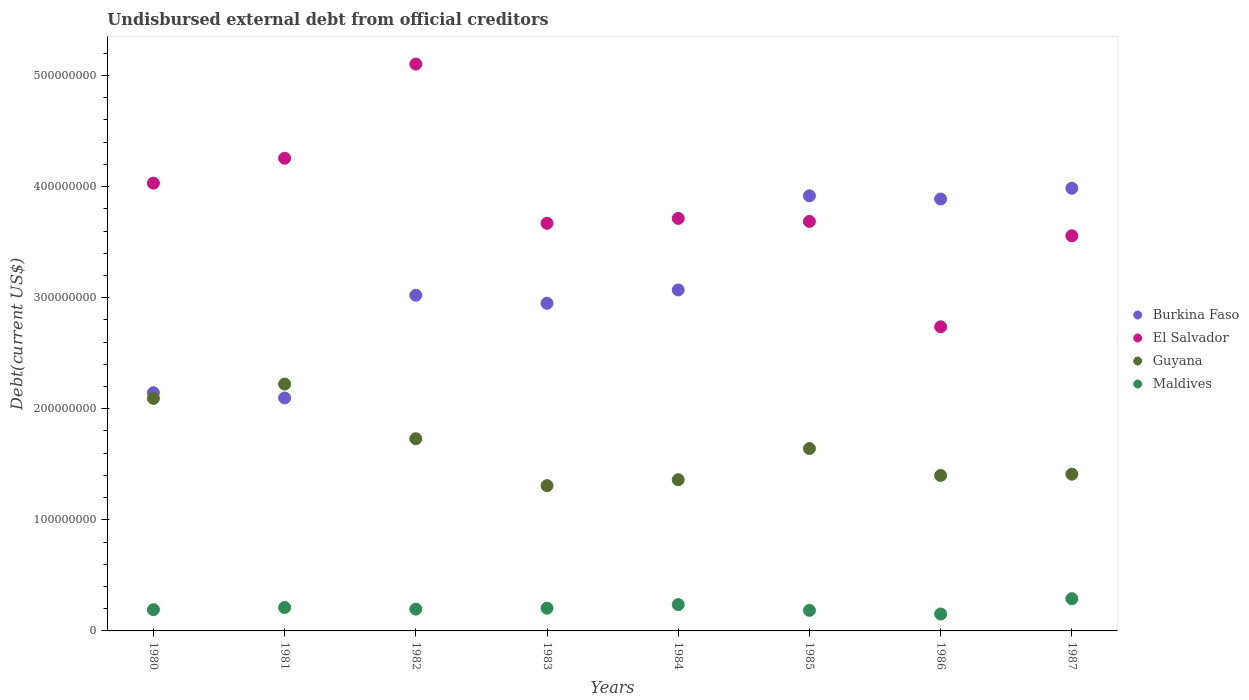What is the total debt in Burkina Faso in 1985?
Keep it short and to the point. 3.92e+08. Across all years, what is the maximum total debt in Guyana?
Your response must be concise. 2.22e+08. Across all years, what is the minimum total debt in Burkina Faso?
Your response must be concise. 2.10e+08. In which year was the total debt in Burkina Faso maximum?
Offer a terse response. 1987. What is the total total debt in Burkina Faso in the graph?
Offer a very short reply. 2.51e+09. What is the difference between the total debt in Maldives in 1980 and that in 1985?
Your answer should be very brief. 6.35e+05. What is the difference between the total debt in Maldives in 1985 and the total debt in Burkina Faso in 1986?
Make the answer very short. -3.70e+08. What is the average total debt in El Salvador per year?
Ensure brevity in your answer.  3.84e+08. In the year 1983, what is the difference between the total debt in Maldives and total debt in El Salvador?
Your answer should be very brief. -3.47e+08. What is the ratio of the total debt in Guyana in 1983 to that in 1984?
Your response must be concise. 0.96. Is the total debt in Burkina Faso in 1980 less than that in 1985?
Make the answer very short. Yes. What is the difference between the highest and the second highest total debt in El Salvador?
Ensure brevity in your answer.  8.48e+07. What is the difference between the highest and the lowest total debt in Burkina Faso?
Make the answer very short. 1.89e+08. Is it the case that in every year, the sum of the total debt in Burkina Faso and total debt in El Salvador  is greater than the total debt in Guyana?
Make the answer very short. Yes. Does the total debt in El Salvador monotonically increase over the years?
Provide a succinct answer. No. How many dotlines are there?
Provide a short and direct response. 4. Where does the legend appear in the graph?
Provide a succinct answer. Center right. What is the title of the graph?
Keep it short and to the point. Undisbursed external debt from official creditors. What is the label or title of the X-axis?
Ensure brevity in your answer.  Years. What is the label or title of the Y-axis?
Your answer should be very brief. Debt(current US$). What is the Debt(current US$) of Burkina Faso in 1980?
Your response must be concise. 2.14e+08. What is the Debt(current US$) in El Salvador in 1980?
Your response must be concise. 4.03e+08. What is the Debt(current US$) of Guyana in 1980?
Ensure brevity in your answer.  2.09e+08. What is the Debt(current US$) of Maldives in 1980?
Make the answer very short. 1.91e+07. What is the Debt(current US$) of Burkina Faso in 1981?
Your response must be concise. 2.10e+08. What is the Debt(current US$) in El Salvador in 1981?
Your response must be concise. 4.26e+08. What is the Debt(current US$) of Guyana in 1981?
Offer a terse response. 2.22e+08. What is the Debt(current US$) in Maldives in 1981?
Provide a succinct answer. 2.11e+07. What is the Debt(current US$) of Burkina Faso in 1982?
Your answer should be compact. 3.02e+08. What is the Debt(current US$) in El Salvador in 1982?
Your answer should be compact. 5.10e+08. What is the Debt(current US$) of Guyana in 1982?
Ensure brevity in your answer.  1.73e+08. What is the Debt(current US$) in Maldives in 1982?
Offer a very short reply. 1.96e+07. What is the Debt(current US$) in Burkina Faso in 1983?
Keep it short and to the point. 2.95e+08. What is the Debt(current US$) of El Salvador in 1983?
Your answer should be very brief. 3.67e+08. What is the Debt(current US$) in Guyana in 1983?
Offer a terse response. 1.31e+08. What is the Debt(current US$) in Maldives in 1983?
Offer a terse response. 2.05e+07. What is the Debt(current US$) in Burkina Faso in 1984?
Your response must be concise. 3.07e+08. What is the Debt(current US$) in El Salvador in 1984?
Keep it short and to the point. 3.71e+08. What is the Debt(current US$) of Guyana in 1984?
Your answer should be compact. 1.36e+08. What is the Debt(current US$) of Maldives in 1984?
Your response must be concise. 2.37e+07. What is the Debt(current US$) in Burkina Faso in 1985?
Provide a succinct answer. 3.92e+08. What is the Debt(current US$) of El Salvador in 1985?
Keep it short and to the point. 3.69e+08. What is the Debt(current US$) in Guyana in 1985?
Your answer should be very brief. 1.64e+08. What is the Debt(current US$) of Maldives in 1985?
Offer a very short reply. 1.85e+07. What is the Debt(current US$) of Burkina Faso in 1986?
Your answer should be compact. 3.89e+08. What is the Debt(current US$) in El Salvador in 1986?
Offer a terse response. 2.74e+08. What is the Debt(current US$) of Guyana in 1986?
Offer a very short reply. 1.40e+08. What is the Debt(current US$) of Maldives in 1986?
Your answer should be compact. 1.52e+07. What is the Debt(current US$) in Burkina Faso in 1987?
Ensure brevity in your answer.  3.98e+08. What is the Debt(current US$) in El Salvador in 1987?
Offer a terse response. 3.56e+08. What is the Debt(current US$) of Guyana in 1987?
Offer a very short reply. 1.41e+08. What is the Debt(current US$) of Maldives in 1987?
Your response must be concise. 2.90e+07. Across all years, what is the maximum Debt(current US$) in Burkina Faso?
Your answer should be very brief. 3.98e+08. Across all years, what is the maximum Debt(current US$) of El Salvador?
Keep it short and to the point. 5.10e+08. Across all years, what is the maximum Debt(current US$) in Guyana?
Make the answer very short. 2.22e+08. Across all years, what is the maximum Debt(current US$) of Maldives?
Your answer should be very brief. 2.90e+07. Across all years, what is the minimum Debt(current US$) in Burkina Faso?
Your answer should be compact. 2.10e+08. Across all years, what is the minimum Debt(current US$) of El Salvador?
Provide a short and direct response. 2.74e+08. Across all years, what is the minimum Debt(current US$) in Guyana?
Offer a very short reply. 1.31e+08. Across all years, what is the minimum Debt(current US$) of Maldives?
Give a very brief answer. 1.52e+07. What is the total Debt(current US$) of Burkina Faso in the graph?
Provide a succinct answer. 2.51e+09. What is the total Debt(current US$) in El Salvador in the graph?
Ensure brevity in your answer.  3.08e+09. What is the total Debt(current US$) of Guyana in the graph?
Offer a terse response. 1.32e+09. What is the total Debt(current US$) in Maldives in the graph?
Provide a succinct answer. 1.67e+08. What is the difference between the Debt(current US$) of Burkina Faso in 1980 and that in 1981?
Give a very brief answer. 4.70e+06. What is the difference between the Debt(current US$) of El Salvador in 1980 and that in 1981?
Offer a very short reply. -2.24e+07. What is the difference between the Debt(current US$) in Guyana in 1980 and that in 1981?
Make the answer very short. -1.29e+07. What is the difference between the Debt(current US$) in Maldives in 1980 and that in 1981?
Keep it short and to the point. -1.99e+06. What is the difference between the Debt(current US$) in Burkina Faso in 1980 and that in 1982?
Your answer should be very brief. -8.78e+07. What is the difference between the Debt(current US$) in El Salvador in 1980 and that in 1982?
Provide a succinct answer. -1.07e+08. What is the difference between the Debt(current US$) in Guyana in 1980 and that in 1982?
Make the answer very short. 3.63e+07. What is the difference between the Debt(current US$) in Maldives in 1980 and that in 1982?
Your answer should be compact. -4.82e+05. What is the difference between the Debt(current US$) of Burkina Faso in 1980 and that in 1983?
Give a very brief answer. -8.05e+07. What is the difference between the Debt(current US$) in El Salvador in 1980 and that in 1983?
Offer a very short reply. 3.61e+07. What is the difference between the Debt(current US$) in Guyana in 1980 and that in 1983?
Your answer should be very brief. 7.85e+07. What is the difference between the Debt(current US$) of Maldives in 1980 and that in 1983?
Provide a succinct answer. -1.34e+06. What is the difference between the Debt(current US$) of Burkina Faso in 1980 and that in 1984?
Make the answer very short. -9.26e+07. What is the difference between the Debt(current US$) of El Salvador in 1980 and that in 1984?
Provide a short and direct response. 3.18e+07. What is the difference between the Debt(current US$) in Guyana in 1980 and that in 1984?
Your response must be concise. 7.32e+07. What is the difference between the Debt(current US$) in Maldives in 1980 and that in 1984?
Offer a terse response. -4.59e+06. What is the difference between the Debt(current US$) of Burkina Faso in 1980 and that in 1985?
Your answer should be compact. -1.77e+08. What is the difference between the Debt(current US$) of El Salvador in 1980 and that in 1985?
Provide a succinct answer. 3.45e+07. What is the difference between the Debt(current US$) of Guyana in 1980 and that in 1985?
Provide a short and direct response. 4.51e+07. What is the difference between the Debt(current US$) in Maldives in 1980 and that in 1985?
Make the answer very short. 6.35e+05. What is the difference between the Debt(current US$) of Burkina Faso in 1980 and that in 1986?
Provide a succinct answer. -1.74e+08. What is the difference between the Debt(current US$) of El Salvador in 1980 and that in 1986?
Your answer should be compact. 1.29e+08. What is the difference between the Debt(current US$) of Guyana in 1980 and that in 1986?
Give a very brief answer. 6.93e+07. What is the difference between the Debt(current US$) in Maldives in 1980 and that in 1986?
Provide a succinct answer. 3.90e+06. What is the difference between the Debt(current US$) in Burkina Faso in 1980 and that in 1987?
Ensure brevity in your answer.  -1.84e+08. What is the difference between the Debt(current US$) of El Salvador in 1980 and that in 1987?
Make the answer very short. 4.74e+07. What is the difference between the Debt(current US$) in Guyana in 1980 and that in 1987?
Make the answer very short. 6.82e+07. What is the difference between the Debt(current US$) in Maldives in 1980 and that in 1987?
Give a very brief answer. -9.90e+06. What is the difference between the Debt(current US$) of Burkina Faso in 1981 and that in 1982?
Offer a terse response. -9.25e+07. What is the difference between the Debt(current US$) in El Salvador in 1981 and that in 1982?
Provide a short and direct response. -8.48e+07. What is the difference between the Debt(current US$) in Guyana in 1981 and that in 1982?
Provide a succinct answer. 4.92e+07. What is the difference between the Debt(current US$) in Maldives in 1981 and that in 1982?
Give a very brief answer. 1.50e+06. What is the difference between the Debt(current US$) of Burkina Faso in 1981 and that in 1983?
Make the answer very short. -8.52e+07. What is the difference between the Debt(current US$) of El Salvador in 1981 and that in 1983?
Your response must be concise. 5.85e+07. What is the difference between the Debt(current US$) of Guyana in 1981 and that in 1983?
Your answer should be very brief. 9.15e+07. What is the difference between the Debt(current US$) of Maldives in 1981 and that in 1983?
Keep it short and to the point. 6.47e+05. What is the difference between the Debt(current US$) of Burkina Faso in 1981 and that in 1984?
Make the answer very short. -9.73e+07. What is the difference between the Debt(current US$) of El Salvador in 1981 and that in 1984?
Provide a short and direct response. 5.41e+07. What is the difference between the Debt(current US$) of Guyana in 1981 and that in 1984?
Your answer should be compact. 8.61e+07. What is the difference between the Debt(current US$) in Maldives in 1981 and that in 1984?
Give a very brief answer. -2.61e+06. What is the difference between the Debt(current US$) in Burkina Faso in 1981 and that in 1985?
Offer a very short reply. -1.82e+08. What is the difference between the Debt(current US$) in El Salvador in 1981 and that in 1985?
Your answer should be compact. 5.69e+07. What is the difference between the Debt(current US$) in Guyana in 1981 and that in 1985?
Make the answer very short. 5.80e+07. What is the difference between the Debt(current US$) in Maldives in 1981 and that in 1985?
Offer a terse response. 2.62e+06. What is the difference between the Debt(current US$) in Burkina Faso in 1981 and that in 1986?
Offer a terse response. -1.79e+08. What is the difference between the Debt(current US$) of El Salvador in 1981 and that in 1986?
Keep it short and to the point. 1.52e+08. What is the difference between the Debt(current US$) in Guyana in 1981 and that in 1986?
Give a very brief answer. 8.23e+07. What is the difference between the Debt(current US$) in Maldives in 1981 and that in 1986?
Keep it short and to the point. 5.89e+06. What is the difference between the Debt(current US$) of Burkina Faso in 1981 and that in 1987?
Keep it short and to the point. -1.89e+08. What is the difference between the Debt(current US$) of El Salvador in 1981 and that in 1987?
Provide a short and direct response. 6.98e+07. What is the difference between the Debt(current US$) of Guyana in 1981 and that in 1987?
Give a very brief answer. 8.11e+07. What is the difference between the Debt(current US$) in Maldives in 1981 and that in 1987?
Keep it short and to the point. -7.91e+06. What is the difference between the Debt(current US$) in Burkina Faso in 1982 and that in 1983?
Offer a terse response. 7.24e+06. What is the difference between the Debt(current US$) of El Salvador in 1982 and that in 1983?
Your answer should be very brief. 1.43e+08. What is the difference between the Debt(current US$) in Guyana in 1982 and that in 1983?
Give a very brief answer. 4.23e+07. What is the difference between the Debt(current US$) of Maldives in 1982 and that in 1983?
Your answer should be compact. -8.57e+05. What is the difference between the Debt(current US$) in Burkina Faso in 1982 and that in 1984?
Make the answer very short. -4.80e+06. What is the difference between the Debt(current US$) of El Salvador in 1982 and that in 1984?
Offer a very short reply. 1.39e+08. What is the difference between the Debt(current US$) of Guyana in 1982 and that in 1984?
Ensure brevity in your answer.  3.69e+07. What is the difference between the Debt(current US$) of Maldives in 1982 and that in 1984?
Give a very brief answer. -4.11e+06. What is the difference between the Debt(current US$) of Burkina Faso in 1982 and that in 1985?
Make the answer very short. -8.95e+07. What is the difference between the Debt(current US$) of El Salvador in 1982 and that in 1985?
Your response must be concise. 1.42e+08. What is the difference between the Debt(current US$) of Guyana in 1982 and that in 1985?
Provide a short and direct response. 8.86e+06. What is the difference between the Debt(current US$) of Maldives in 1982 and that in 1985?
Your response must be concise. 1.12e+06. What is the difference between the Debt(current US$) in Burkina Faso in 1982 and that in 1986?
Your response must be concise. -8.66e+07. What is the difference between the Debt(current US$) of El Salvador in 1982 and that in 1986?
Offer a very short reply. 2.37e+08. What is the difference between the Debt(current US$) in Guyana in 1982 and that in 1986?
Offer a very short reply. 3.31e+07. What is the difference between the Debt(current US$) in Maldives in 1982 and that in 1986?
Provide a succinct answer. 4.38e+06. What is the difference between the Debt(current US$) of Burkina Faso in 1982 and that in 1987?
Offer a very short reply. -9.63e+07. What is the difference between the Debt(current US$) of El Salvador in 1982 and that in 1987?
Keep it short and to the point. 1.55e+08. What is the difference between the Debt(current US$) of Guyana in 1982 and that in 1987?
Offer a terse response. 3.19e+07. What is the difference between the Debt(current US$) in Maldives in 1982 and that in 1987?
Your response must be concise. -9.42e+06. What is the difference between the Debt(current US$) of Burkina Faso in 1983 and that in 1984?
Keep it short and to the point. -1.20e+07. What is the difference between the Debt(current US$) of El Salvador in 1983 and that in 1984?
Offer a terse response. -4.39e+06. What is the difference between the Debt(current US$) in Guyana in 1983 and that in 1984?
Your response must be concise. -5.34e+06. What is the difference between the Debt(current US$) in Maldives in 1983 and that in 1984?
Keep it short and to the point. -3.25e+06. What is the difference between the Debt(current US$) of Burkina Faso in 1983 and that in 1985?
Ensure brevity in your answer.  -9.68e+07. What is the difference between the Debt(current US$) of El Salvador in 1983 and that in 1985?
Offer a very short reply. -1.68e+06. What is the difference between the Debt(current US$) in Guyana in 1983 and that in 1985?
Provide a short and direct response. -3.34e+07. What is the difference between the Debt(current US$) in Maldives in 1983 and that in 1985?
Make the answer very short. 1.97e+06. What is the difference between the Debt(current US$) in Burkina Faso in 1983 and that in 1986?
Give a very brief answer. -9.39e+07. What is the difference between the Debt(current US$) of El Salvador in 1983 and that in 1986?
Give a very brief answer. 9.32e+07. What is the difference between the Debt(current US$) in Guyana in 1983 and that in 1986?
Your answer should be compact. -9.17e+06. What is the difference between the Debt(current US$) in Maldives in 1983 and that in 1986?
Ensure brevity in your answer.  5.24e+06. What is the difference between the Debt(current US$) of Burkina Faso in 1983 and that in 1987?
Make the answer very short. -1.04e+08. What is the difference between the Debt(current US$) of El Salvador in 1983 and that in 1987?
Your answer should be very brief. 1.13e+07. What is the difference between the Debt(current US$) of Guyana in 1983 and that in 1987?
Ensure brevity in your answer.  -1.03e+07. What is the difference between the Debt(current US$) in Maldives in 1983 and that in 1987?
Offer a terse response. -8.56e+06. What is the difference between the Debt(current US$) of Burkina Faso in 1984 and that in 1985?
Keep it short and to the point. -8.47e+07. What is the difference between the Debt(current US$) of El Salvador in 1984 and that in 1985?
Your response must be concise. 2.71e+06. What is the difference between the Debt(current US$) in Guyana in 1984 and that in 1985?
Your response must be concise. -2.81e+07. What is the difference between the Debt(current US$) in Maldives in 1984 and that in 1985?
Offer a terse response. 5.23e+06. What is the difference between the Debt(current US$) of Burkina Faso in 1984 and that in 1986?
Your answer should be compact. -8.18e+07. What is the difference between the Debt(current US$) of El Salvador in 1984 and that in 1986?
Ensure brevity in your answer.  9.76e+07. What is the difference between the Debt(current US$) in Guyana in 1984 and that in 1986?
Make the answer very short. -3.84e+06. What is the difference between the Debt(current US$) of Maldives in 1984 and that in 1986?
Make the answer very short. 8.49e+06. What is the difference between the Debt(current US$) of Burkina Faso in 1984 and that in 1987?
Offer a very short reply. -9.15e+07. What is the difference between the Debt(current US$) in El Salvador in 1984 and that in 1987?
Keep it short and to the point. 1.56e+07. What is the difference between the Debt(current US$) of Guyana in 1984 and that in 1987?
Make the answer very short. -4.99e+06. What is the difference between the Debt(current US$) of Maldives in 1984 and that in 1987?
Your answer should be very brief. -5.31e+06. What is the difference between the Debt(current US$) of Burkina Faso in 1985 and that in 1986?
Your answer should be compact. 2.89e+06. What is the difference between the Debt(current US$) of El Salvador in 1985 and that in 1986?
Provide a short and direct response. 9.49e+07. What is the difference between the Debt(current US$) of Guyana in 1985 and that in 1986?
Offer a very short reply. 2.42e+07. What is the difference between the Debt(current US$) of Maldives in 1985 and that in 1986?
Offer a very short reply. 3.27e+06. What is the difference between the Debt(current US$) of Burkina Faso in 1985 and that in 1987?
Provide a succinct answer. -6.79e+06. What is the difference between the Debt(current US$) in El Salvador in 1985 and that in 1987?
Give a very brief answer. 1.29e+07. What is the difference between the Debt(current US$) of Guyana in 1985 and that in 1987?
Your answer should be compact. 2.31e+07. What is the difference between the Debt(current US$) in Maldives in 1985 and that in 1987?
Make the answer very short. -1.05e+07. What is the difference between the Debt(current US$) in Burkina Faso in 1986 and that in 1987?
Provide a succinct answer. -9.67e+06. What is the difference between the Debt(current US$) of El Salvador in 1986 and that in 1987?
Keep it short and to the point. -8.19e+07. What is the difference between the Debt(current US$) in Guyana in 1986 and that in 1987?
Provide a short and direct response. -1.16e+06. What is the difference between the Debt(current US$) of Maldives in 1986 and that in 1987?
Your answer should be very brief. -1.38e+07. What is the difference between the Debt(current US$) in Burkina Faso in 1980 and the Debt(current US$) in El Salvador in 1981?
Your answer should be very brief. -2.11e+08. What is the difference between the Debt(current US$) of Burkina Faso in 1980 and the Debt(current US$) of Guyana in 1981?
Ensure brevity in your answer.  -7.81e+06. What is the difference between the Debt(current US$) of Burkina Faso in 1980 and the Debt(current US$) of Maldives in 1981?
Provide a succinct answer. 1.93e+08. What is the difference between the Debt(current US$) of El Salvador in 1980 and the Debt(current US$) of Guyana in 1981?
Your answer should be very brief. 1.81e+08. What is the difference between the Debt(current US$) of El Salvador in 1980 and the Debt(current US$) of Maldives in 1981?
Your response must be concise. 3.82e+08. What is the difference between the Debt(current US$) in Guyana in 1980 and the Debt(current US$) in Maldives in 1981?
Make the answer very short. 1.88e+08. What is the difference between the Debt(current US$) of Burkina Faso in 1980 and the Debt(current US$) of El Salvador in 1982?
Offer a very short reply. -2.96e+08. What is the difference between the Debt(current US$) in Burkina Faso in 1980 and the Debt(current US$) in Guyana in 1982?
Ensure brevity in your answer.  4.14e+07. What is the difference between the Debt(current US$) of Burkina Faso in 1980 and the Debt(current US$) of Maldives in 1982?
Your response must be concise. 1.95e+08. What is the difference between the Debt(current US$) of El Salvador in 1980 and the Debt(current US$) of Guyana in 1982?
Your answer should be very brief. 2.30e+08. What is the difference between the Debt(current US$) in El Salvador in 1980 and the Debt(current US$) in Maldives in 1982?
Your answer should be very brief. 3.84e+08. What is the difference between the Debt(current US$) of Guyana in 1980 and the Debt(current US$) of Maldives in 1982?
Keep it short and to the point. 1.90e+08. What is the difference between the Debt(current US$) in Burkina Faso in 1980 and the Debt(current US$) in El Salvador in 1983?
Offer a very short reply. -1.53e+08. What is the difference between the Debt(current US$) of Burkina Faso in 1980 and the Debt(current US$) of Guyana in 1983?
Provide a short and direct response. 8.36e+07. What is the difference between the Debt(current US$) of Burkina Faso in 1980 and the Debt(current US$) of Maldives in 1983?
Your answer should be compact. 1.94e+08. What is the difference between the Debt(current US$) of El Salvador in 1980 and the Debt(current US$) of Guyana in 1983?
Make the answer very short. 2.72e+08. What is the difference between the Debt(current US$) in El Salvador in 1980 and the Debt(current US$) in Maldives in 1983?
Give a very brief answer. 3.83e+08. What is the difference between the Debt(current US$) in Guyana in 1980 and the Debt(current US$) in Maldives in 1983?
Your answer should be very brief. 1.89e+08. What is the difference between the Debt(current US$) of Burkina Faso in 1980 and the Debt(current US$) of El Salvador in 1984?
Ensure brevity in your answer.  -1.57e+08. What is the difference between the Debt(current US$) in Burkina Faso in 1980 and the Debt(current US$) in Guyana in 1984?
Offer a terse response. 7.83e+07. What is the difference between the Debt(current US$) of Burkina Faso in 1980 and the Debt(current US$) of Maldives in 1984?
Keep it short and to the point. 1.91e+08. What is the difference between the Debt(current US$) in El Salvador in 1980 and the Debt(current US$) in Guyana in 1984?
Offer a very short reply. 2.67e+08. What is the difference between the Debt(current US$) in El Salvador in 1980 and the Debt(current US$) in Maldives in 1984?
Your answer should be very brief. 3.79e+08. What is the difference between the Debt(current US$) of Guyana in 1980 and the Debt(current US$) of Maldives in 1984?
Make the answer very short. 1.86e+08. What is the difference between the Debt(current US$) in Burkina Faso in 1980 and the Debt(current US$) in El Salvador in 1985?
Your response must be concise. -1.54e+08. What is the difference between the Debt(current US$) in Burkina Faso in 1980 and the Debt(current US$) in Guyana in 1985?
Your response must be concise. 5.02e+07. What is the difference between the Debt(current US$) in Burkina Faso in 1980 and the Debt(current US$) in Maldives in 1985?
Provide a succinct answer. 1.96e+08. What is the difference between the Debt(current US$) in El Salvador in 1980 and the Debt(current US$) in Guyana in 1985?
Make the answer very short. 2.39e+08. What is the difference between the Debt(current US$) in El Salvador in 1980 and the Debt(current US$) in Maldives in 1985?
Your response must be concise. 3.85e+08. What is the difference between the Debt(current US$) of Guyana in 1980 and the Debt(current US$) of Maldives in 1985?
Offer a very short reply. 1.91e+08. What is the difference between the Debt(current US$) of Burkina Faso in 1980 and the Debt(current US$) of El Salvador in 1986?
Your answer should be very brief. -5.94e+07. What is the difference between the Debt(current US$) in Burkina Faso in 1980 and the Debt(current US$) in Guyana in 1986?
Make the answer very short. 7.45e+07. What is the difference between the Debt(current US$) of Burkina Faso in 1980 and the Debt(current US$) of Maldives in 1986?
Provide a succinct answer. 1.99e+08. What is the difference between the Debt(current US$) of El Salvador in 1980 and the Debt(current US$) of Guyana in 1986?
Give a very brief answer. 2.63e+08. What is the difference between the Debt(current US$) in El Salvador in 1980 and the Debt(current US$) in Maldives in 1986?
Your response must be concise. 3.88e+08. What is the difference between the Debt(current US$) of Guyana in 1980 and the Debt(current US$) of Maldives in 1986?
Make the answer very short. 1.94e+08. What is the difference between the Debt(current US$) in Burkina Faso in 1980 and the Debt(current US$) in El Salvador in 1987?
Ensure brevity in your answer.  -1.41e+08. What is the difference between the Debt(current US$) of Burkina Faso in 1980 and the Debt(current US$) of Guyana in 1987?
Provide a succinct answer. 7.33e+07. What is the difference between the Debt(current US$) of Burkina Faso in 1980 and the Debt(current US$) of Maldives in 1987?
Ensure brevity in your answer.  1.85e+08. What is the difference between the Debt(current US$) in El Salvador in 1980 and the Debt(current US$) in Guyana in 1987?
Your answer should be very brief. 2.62e+08. What is the difference between the Debt(current US$) in El Salvador in 1980 and the Debt(current US$) in Maldives in 1987?
Provide a succinct answer. 3.74e+08. What is the difference between the Debt(current US$) in Guyana in 1980 and the Debt(current US$) in Maldives in 1987?
Provide a succinct answer. 1.80e+08. What is the difference between the Debt(current US$) of Burkina Faso in 1981 and the Debt(current US$) of El Salvador in 1982?
Offer a very short reply. -3.01e+08. What is the difference between the Debt(current US$) of Burkina Faso in 1981 and the Debt(current US$) of Guyana in 1982?
Provide a short and direct response. 3.67e+07. What is the difference between the Debt(current US$) in Burkina Faso in 1981 and the Debt(current US$) in Maldives in 1982?
Give a very brief answer. 1.90e+08. What is the difference between the Debt(current US$) of El Salvador in 1981 and the Debt(current US$) of Guyana in 1982?
Provide a succinct answer. 2.52e+08. What is the difference between the Debt(current US$) of El Salvador in 1981 and the Debt(current US$) of Maldives in 1982?
Your response must be concise. 4.06e+08. What is the difference between the Debt(current US$) in Guyana in 1981 and the Debt(current US$) in Maldives in 1982?
Your answer should be very brief. 2.03e+08. What is the difference between the Debt(current US$) of Burkina Faso in 1981 and the Debt(current US$) of El Salvador in 1983?
Ensure brevity in your answer.  -1.57e+08. What is the difference between the Debt(current US$) of Burkina Faso in 1981 and the Debt(current US$) of Guyana in 1983?
Ensure brevity in your answer.  7.89e+07. What is the difference between the Debt(current US$) in Burkina Faso in 1981 and the Debt(current US$) in Maldives in 1983?
Keep it short and to the point. 1.89e+08. What is the difference between the Debt(current US$) in El Salvador in 1981 and the Debt(current US$) in Guyana in 1983?
Your answer should be compact. 2.95e+08. What is the difference between the Debt(current US$) in El Salvador in 1981 and the Debt(current US$) in Maldives in 1983?
Give a very brief answer. 4.05e+08. What is the difference between the Debt(current US$) in Guyana in 1981 and the Debt(current US$) in Maldives in 1983?
Your answer should be compact. 2.02e+08. What is the difference between the Debt(current US$) of Burkina Faso in 1981 and the Debt(current US$) of El Salvador in 1984?
Your answer should be compact. -1.62e+08. What is the difference between the Debt(current US$) of Burkina Faso in 1981 and the Debt(current US$) of Guyana in 1984?
Provide a short and direct response. 7.36e+07. What is the difference between the Debt(current US$) in Burkina Faso in 1981 and the Debt(current US$) in Maldives in 1984?
Provide a succinct answer. 1.86e+08. What is the difference between the Debt(current US$) in El Salvador in 1981 and the Debt(current US$) in Guyana in 1984?
Make the answer very short. 2.89e+08. What is the difference between the Debt(current US$) in El Salvador in 1981 and the Debt(current US$) in Maldives in 1984?
Offer a terse response. 4.02e+08. What is the difference between the Debt(current US$) of Guyana in 1981 and the Debt(current US$) of Maldives in 1984?
Provide a succinct answer. 1.99e+08. What is the difference between the Debt(current US$) of Burkina Faso in 1981 and the Debt(current US$) of El Salvador in 1985?
Offer a terse response. -1.59e+08. What is the difference between the Debt(current US$) in Burkina Faso in 1981 and the Debt(current US$) in Guyana in 1985?
Offer a terse response. 4.55e+07. What is the difference between the Debt(current US$) in Burkina Faso in 1981 and the Debt(current US$) in Maldives in 1985?
Your answer should be compact. 1.91e+08. What is the difference between the Debt(current US$) of El Salvador in 1981 and the Debt(current US$) of Guyana in 1985?
Offer a very short reply. 2.61e+08. What is the difference between the Debt(current US$) in El Salvador in 1981 and the Debt(current US$) in Maldives in 1985?
Provide a succinct answer. 4.07e+08. What is the difference between the Debt(current US$) in Guyana in 1981 and the Debt(current US$) in Maldives in 1985?
Keep it short and to the point. 2.04e+08. What is the difference between the Debt(current US$) of Burkina Faso in 1981 and the Debt(current US$) of El Salvador in 1986?
Provide a short and direct response. -6.41e+07. What is the difference between the Debt(current US$) in Burkina Faso in 1981 and the Debt(current US$) in Guyana in 1986?
Your answer should be very brief. 6.98e+07. What is the difference between the Debt(current US$) in Burkina Faso in 1981 and the Debt(current US$) in Maldives in 1986?
Make the answer very short. 1.94e+08. What is the difference between the Debt(current US$) of El Salvador in 1981 and the Debt(current US$) of Guyana in 1986?
Your response must be concise. 2.86e+08. What is the difference between the Debt(current US$) of El Salvador in 1981 and the Debt(current US$) of Maldives in 1986?
Provide a short and direct response. 4.10e+08. What is the difference between the Debt(current US$) of Guyana in 1981 and the Debt(current US$) of Maldives in 1986?
Ensure brevity in your answer.  2.07e+08. What is the difference between the Debt(current US$) in Burkina Faso in 1981 and the Debt(current US$) in El Salvador in 1987?
Your answer should be compact. -1.46e+08. What is the difference between the Debt(current US$) of Burkina Faso in 1981 and the Debt(current US$) of Guyana in 1987?
Your answer should be compact. 6.86e+07. What is the difference between the Debt(current US$) in Burkina Faso in 1981 and the Debt(current US$) in Maldives in 1987?
Your response must be concise. 1.81e+08. What is the difference between the Debt(current US$) in El Salvador in 1981 and the Debt(current US$) in Guyana in 1987?
Provide a short and direct response. 2.84e+08. What is the difference between the Debt(current US$) of El Salvador in 1981 and the Debt(current US$) of Maldives in 1987?
Make the answer very short. 3.96e+08. What is the difference between the Debt(current US$) of Guyana in 1981 and the Debt(current US$) of Maldives in 1987?
Provide a short and direct response. 1.93e+08. What is the difference between the Debt(current US$) of Burkina Faso in 1982 and the Debt(current US$) of El Salvador in 1983?
Your response must be concise. -6.48e+07. What is the difference between the Debt(current US$) in Burkina Faso in 1982 and the Debt(current US$) in Guyana in 1983?
Offer a terse response. 1.71e+08. What is the difference between the Debt(current US$) in Burkina Faso in 1982 and the Debt(current US$) in Maldives in 1983?
Keep it short and to the point. 2.82e+08. What is the difference between the Debt(current US$) in El Salvador in 1982 and the Debt(current US$) in Guyana in 1983?
Keep it short and to the point. 3.80e+08. What is the difference between the Debt(current US$) of El Salvador in 1982 and the Debt(current US$) of Maldives in 1983?
Provide a succinct answer. 4.90e+08. What is the difference between the Debt(current US$) in Guyana in 1982 and the Debt(current US$) in Maldives in 1983?
Your response must be concise. 1.53e+08. What is the difference between the Debt(current US$) in Burkina Faso in 1982 and the Debt(current US$) in El Salvador in 1984?
Offer a very short reply. -6.92e+07. What is the difference between the Debt(current US$) in Burkina Faso in 1982 and the Debt(current US$) in Guyana in 1984?
Your response must be concise. 1.66e+08. What is the difference between the Debt(current US$) in Burkina Faso in 1982 and the Debt(current US$) in Maldives in 1984?
Offer a terse response. 2.78e+08. What is the difference between the Debt(current US$) in El Salvador in 1982 and the Debt(current US$) in Guyana in 1984?
Keep it short and to the point. 3.74e+08. What is the difference between the Debt(current US$) in El Salvador in 1982 and the Debt(current US$) in Maldives in 1984?
Make the answer very short. 4.87e+08. What is the difference between the Debt(current US$) of Guyana in 1982 and the Debt(current US$) of Maldives in 1984?
Make the answer very short. 1.49e+08. What is the difference between the Debt(current US$) in Burkina Faso in 1982 and the Debt(current US$) in El Salvador in 1985?
Provide a short and direct response. -6.65e+07. What is the difference between the Debt(current US$) of Burkina Faso in 1982 and the Debt(current US$) of Guyana in 1985?
Offer a very short reply. 1.38e+08. What is the difference between the Debt(current US$) of Burkina Faso in 1982 and the Debt(current US$) of Maldives in 1985?
Provide a short and direct response. 2.84e+08. What is the difference between the Debt(current US$) of El Salvador in 1982 and the Debt(current US$) of Guyana in 1985?
Offer a terse response. 3.46e+08. What is the difference between the Debt(current US$) in El Salvador in 1982 and the Debt(current US$) in Maldives in 1985?
Your response must be concise. 4.92e+08. What is the difference between the Debt(current US$) in Guyana in 1982 and the Debt(current US$) in Maldives in 1985?
Give a very brief answer. 1.55e+08. What is the difference between the Debt(current US$) in Burkina Faso in 1982 and the Debt(current US$) in El Salvador in 1986?
Give a very brief answer. 2.84e+07. What is the difference between the Debt(current US$) of Burkina Faso in 1982 and the Debt(current US$) of Guyana in 1986?
Your answer should be compact. 1.62e+08. What is the difference between the Debt(current US$) of Burkina Faso in 1982 and the Debt(current US$) of Maldives in 1986?
Your answer should be very brief. 2.87e+08. What is the difference between the Debt(current US$) of El Salvador in 1982 and the Debt(current US$) of Guyana in 1986?
Your answer should be compact. 3.70e+08. What is the difference between the Debt(current US$) in El Salvador in 1982 and the Debt(current US$) in Maldives in 1986?
Offer a terse response. 4.95e+08. What is the difference between the Debt(current US$) in Guyana in 1982 and the Debt(current US$) in Maldives in 1986?
Make the answer very short. 1.58e+08. What is the difference between the Debt(current US$) in Burkina Faso in 1982 and the Debt(current US$) in El Salvador in 1987?
Offer a very short reply. -5.35e+07. What is the difference between the Debt(current US$) of Burkina Faso in 1982 and the Debt(current US$) of Guyana in 1987?
Offer a terse response. 1.61e+08. What is the difference between the Debt(current US$) in Burkina Faso in 1982 and the Debt(current US$) in Maldives in 1987?
Provide a short and direct response. 2.73e+08. What is the difference between the Debt(current US$) in El Salvador in 1982 and the Debt(current US$) in Guyana in 1987?
Your response must be concise. 3.69e+08. What is the difference between the Debt(current US$) in El Salvador in 1982 and the Debt(current US$) in Maldives in 1987?
Provide a short and direct response. 4.81e+08. What is the difference between the Debt(current US$) in Guyana in 1982 and the Debt(current US$) in Maldives in 1987?
Offer a very short reply. 1.44e+08. What is the difference between the Debt(current US$) in Burkina Faso in 1983 and the Debt(current US$) in El Salvador in 1984?
Provide a short and direct response. -7.64e+07. What is the difference between the Debt(current US$) in Burkina Faso in 1983 and the Debt(current US$) in Guyana in 1984?
Offer a very short reply. 1.59e+08. What is the difference between the Debt(current US$) in Burkina Faso in 1983 and the Debt(current US$) in Maldives in 1984?
Ensure brevity in your answer.  2.71e+08. What is the difference between the Debt(current US$) of El Salvador in 1983 and the Debt(current US$) of Guyana in 1984?
Give a very brief answer. 2.31e+08. What is the difference between the Debt(current US$) in El Salvador in 1983 and the Debt(current US$) in Maldives in 1984?
Ensure brevity in your answer.  3.43e+08. What is the difference between the Debt(current US$) of Guyana in 1983 and the Debt(current US$) of Maldives in 1984?
Offer a very short reply. 1.07e+08. What is the difference between the Debt(current US$) of Burkina Faso in 1983 and the Debt(current US$) of El Salvador in 1985?
Give a very brief answer. -7.37e+07. What is the difference between the Debt(current US$) in Burkina Faso in 1983 and the Debt(current US$) in Guyana in 1985?
Give a very brief answer. 1.31e+08. What is the difference between the Debt(current US$) of Burkina Faso in 1983 and the Debt(current US$) of Maldives in 1985?
Provide a short and direct response. 2.76e+08. What is the difference between the Debt(current US$) in El Salvador in 1983 and the Debt(current US$) in Guyana in 1985?
Offer a very short reply. 2.03e+08. What is the difference between the Debt(current US$) in El Salvador in 1983 and the Debt(current US$) in Maldives in 1985?
Offer a terse response. 3.48e+08. What is the difference between the Debt(current US$) of Guyana in 1983 and the Debt(current US$) of Maldives in 1985?
Ensure brevity in your answer.  1.12e+08. What is the difference between the Debt(current US$) of Burkina Faso in 1983 and the Debt(current US$) of El Salvador in 1986?
Make the answer very short. 2.12e+07. What is the difference between the Debt(current US$) in Burkina Faso in 1983 and the Debt(current US$) in Guyana in 1986?
Your response must be concise. 1.55e+08. What is the difference between the Debt(current US$) in Burkina Faso in 1983 and the Debt(current US$) in Maldives in 1986?
Your answer should be very brief. 2.80e+08. What is the difference between the Debt(current US$) of El Salvador in 1983 and the Debt(current US$) of Guyana in 1986?
Ensure brevity in your answer.  2.27e+08. What is the difference between the Debt(current US$) of El Salvador in 1983 and the Debt(current US$) of Maldives in 1986?
Provide a succinct answer. 3.52e+08. What is the difference between the Debt(current US$) of Guyana in 1983 and the Debt(current US$) of Maldives in 1986?
Your answer should be very brief. 1.16e+08. What is the difference between the Debt(current US$) in Burkina Faso in 1983 and the Debt(current US$) in El Salvador in 1987?
Give a very brief answer. -6.08e+07. What is the difference between the Debt(current US$) in Burkina Faso in 1983 and the Debt(current US$) in Guyana in 1987?
Your response must be concise. 1.54e+08. What is the difference between the Debt(current US$) of Burkina Faso in 1983 and the Debt(current US$) of Maldives in 1987?
Offer a very short reply. 2.66e+08. What is the difference between the Debt(current US$) of El Salvador in 1983 and the Debt(current US$) of Guyana in 1987?
Give a very brief answer. 2.26e+08. What is the difference between the Debt(current US$) of El Salvador in 1983 and the Debt(current US$) of Maldives in 1987?
Your answer should be compact. 3.38e+08. What is the difference between the Debt(current US$) of Guyana in 1983 and the Debt(current US$) of Maldives in 1987?
Your answer should be compact. 1.02e+08. What is the difference between the Debt(current US$) in Burkina Faso in 1984 and the Debt(current US$) in El Salvador in 1985?
Your response must be concise. -6.17e+07. What is the difference between the Debt(current US$) in Burkina Faso in 1984 and the Debt(current US$) in Guyana in 1985?
Your answer should be very brief. 1.43e+08. What is the difference between the Debt(current US$) of Burkina Faso in 1984 and the Debt(current US$) of Maldives in 1985?
Keep it short and to the point. 2.88e+08. What is the difference between the Debt(current US$) in El Salvador in 1984 and the Debt(current US$) in Guyana in 1985?
Your response must be concise. 2.07e+08. What is the difference between the Debt(current US$) of El Salvador in 1984 and the Debt(current US$) of Maldives in 1985?
Offer a very short reply. 3.53e+08. What is the difference between the Debt(current US$) of Guyana in 1984 and the Debt(current US$) of Maldives in 1985?
Offer a very short reply. 1.18e+08. What is the difference between the Debt(current US$) in Burkina Faso in 1984 and the Debt(current US$) in El Salvador in 1986?
Ensure brevity in your answer.  3.32e+07. What is the difference between the Debt(current US$) in Burkina Faso in 1984 and the Debt(current US$) in Guyana in 1986?
Your answer should be compact. 1.67e+08. What is the difference between the Debt(current US$) in Burkina Faso in 1984 and the Debt(current US$) in Maldives in 1986?
Keep it short and to the point. 2.92e+08. What is the difference between the Debt(current US$) in El Salvador in 1984 and the Debt(current US$) in Guyana in 1986?
Your answer should be compact. 2.31e+08. What is the difference between the Debt(current US$) of El Salvador in 1984 and the Debt(current US$) of Maldives in 1986?
Make the answer very short. 3.56e+08. What is the difference between the Debt(current US$) of Guyana in 1984 and the Debt(current US$) of Maldives in 1986?
Your response must be concise. 1.21e+08. What is the difference between the Debt(current US$) of Burkina Faso in 1984 and the Debt(current US$) of El Salvador in 1987?
Provide a succinct answer. -4.87e+07. What is the difference between the Debt(current US$) of Burkina Faso in 1984 and the Debt(current US$) of Guyana in 1987?
Make the answer very short. 1.66e+08. What is the difference between the Debt(current US$) of Burkina Faso in 1984 and the Debt(current US$) of Maldives in 1987?
Offer a very short reply. 2.78e+08. What is the difference between the Debt(current US$) in El Salvador in 1984 and the Debt(current US$) in Guyana in 1987?
Ensure brevity in your answer.  2.30e+08. What is the difference between the Debt(current US$) of El Salvador in 1984 and the Debt(current US$) of Maldives in 1987?
Offer a terse response. 3.42e+08. What is the difference between the Debt(current US$) of Guyana in 1984 and the Debt(current US$) of Maldives in 1987?
Offer a terse response. 1.07e+08. What is the difference between the Debt(current US$) of Burkina Faso in 1985 and the Debt(current US$) of El Salvador in 1986?
Ensure brevity in your answer.  1.18e+08. What is the difference between the Debt(current US$) of Burkina Faso in 1985 and the Debt(current US$) of Guyana in 1986?
Offer a terse response. 2.52e+08. What is the difference between the Debt(current US$) of Burkina Faso in 1985 and the Debt(current US$) of Maldives in 1986?
Your response must be concise. 3.76e+08. What is the difference between the Debt(current US$) in El Salvador in 1985 and the Debt(current US$) in Guyana in 1986?
Make the answer very short. 2.29e+08. What is the difference between the Debt(current US$) in El Salvador in 1985 and the Debt(current US$) in Maldives in 1986?
Provide a succinct answer. 3.53e+08. What is the difference between the Debt(current US$) in Guyana in 1985 and the Debt(current US$) in Maldives in 1986?
Your answer should be very brief. 1.49e+08. What is the difference between the Debt(current US$) of Burkina Faso in 1985 and the Debt(current US$) of El Salvador in 1987?
Provide a short and direct response. 3.60e+07. What is the difference between the Debt(current US$) of Burkina Faso in 1985 and the Debt(current US$) of Guyana in 1987?
Ensure brevity in your answer.  2.51e+08. What is the difference between the Debt(current US$) of Burkina Faso in 1985 and the Debt(current US$) of Maldives in 1987?
Ensure brevity in your answer.  3.63e+08. What is the difference between the Debt(current US$) of El Salvador in 1985 and the Debt(current US$) of Guyana in 1987?
Keep it short and to the point. 2.28e+08. What is the difference between the Debt(current US$) of El Salvador in 1985 and the Debt(current US$) of Maldives in 1987?
Make the answer very short. 3.40e+08. What is the difference between the Debt(current US$) of Guyana in 1985 and the Debt(current US$) of Maldives in 1987?
Keep it short and to the point. 1.35e+08. What is the difference between the Debt(current US$) in Burkina Faso in 1986 and the Debt(current US$) in El Salvador in 1987?
Provide a short and direct response. 3.31e+07. What is the difference between the Debt(current US$) of Burkina Faso in 1986 and the Debt(current US$) of Guyana in 1987?
Provide a short and direct response. 2.48e+08. What is the difference between the Debt(current US$) of Burkina Faso in 1986 and the Debt(current US$) of Maldives in 1987?
Ensure brevity in your answer.  3.60e+08. What is the difference between the Debt(current US$) in El Salvador in 1986 and the Debt(current US$) in Guyana in 1987?
Your response must be concise. 1.33e+08. What is the difference between the Debt(current US$) of El Salvador in 1986 and the Debt(current US$) of Maldives in 1987?
Give a very brief answer. 2.45e+08. What is the difference between the Debt(current US$) in Guyana in 1986 and the Debt(current US$) in Maldives in 1987?
Offer a terse response. 1.11e+08. What is the average Debt(current US$) of Burkina Faso per year?
Provide a succinct answer. 3.13e+08. What is the average Debt(current US$) in El Salvador per year?
Keep it short and to the point. 3.84e+08. What is the average Debt(current US$) of Guyana per year?
Provide a succinct answer. 1.65e+08. What is the average Debt(current US$) in Maldives per year?
Provide a short and direct response. 2.08e+07. In the year 1980, what is the difference between the Debt(current US$) of Burkina Faso and Debt(current US$) of El Salvador?
Your answer should be compact. -1.89e+08. In the year 1980, what is the difference between the Debt(current US$) in Burkina Faso and Debt(current US$) in Guyana?
Your answer should be very brief. 5.12e+06. In the year 1980, what is the difference between the Debt(current US$) in Burkina Faso and Debt(current US$) in Maldives?
Your answer should be compact. 1.95e+08. In the year 1980, what is the difference between the Debt(current US$) of El Salvador and Debt(current US$) of Guyana?
Provide a short and direct response. 1.94e+08. In the year 1980, what is the difference between the Debt(current US$) in El Salvador and Debt(current US$) in Maldives?
Offer a terse response. 3.84e+08. In the year 1980, what is the difference between the Debt(current US$) in Guyana and Debt(current US$) in Maldives?
Your answer should be very brief. 1.90e+08. In the year 1981, what is the difference between the Debt(current US$) of Burkina Faso and Debt(current US$) of El Salvador?
Make the answer very short. -2.16e+08. In the year 1981, what is the difference between the Debt(current US$) in Burkina Faso and Debt(current US$) in Guyana?
Keep it short and to the point. -1.25e+07. In the year 1981, what is the difference between the Debt(current US$) of Burkina Faso and Debt(current US$) of Maldives?
Keep it short and to the point. 1.89e+08. In the year 1981, what is the difference between the Debt(current US$) of El Salvador and Debt(current US$) of Guyana?
Ensure brevity in your answer.  2.03e+08. In the year 1981, what is the difference between the Debt(current US$) in El Salvador and Debt(current US$) in Maldives?
Give a very brief answer. 4.04e+08. In the year 1981, what is the difference between the Debt(current US$) of Guyana and Debt(current US$) of Maldives?
Your answer should be compact. 2.01e+08. In the year 1982, what is the difference between the Debt(current US$) of Burkina Faso and Debt(current US$) of El Salvador?
Offer a very short reply. -2.08e+08. In the year 1982, what is the difference between the Debt(current US$) of Burkina Faso and Debt(current US$) of Guyana?
Keep it short and to the point. 1.29e+08. In the year 1982, what is the difference between the Debt(current US$) in Burkina Faso and Debt(current US$) in Maldives?
Your answer should be very brief. 2.83e+08. In the year 1982, what is the difference between the Debt(current US$) in El Salvador and Debt(current US$) in Guyana?
Ensure brevity in your answer.  3.37e+08. In the year 1982, what is the difference between the Debt(current US$) of El Salvador and Debt(current US$) of Maldives?
Your answer should be very brief. 4.91e+08. In the year 1982, what is the difference between the Debt(current US$) in Guyana and Debt(current US$) in Maldives?
Your answer should be very brief. 1.53e+08. In the year 1983, what is the difference between the Debt(current US$) in Burkina Faso and Debt(current US$) in El Salvador?
Provide a succinct answer. -7.20e+07. In the year 1983, what is the difference between the Debt(current US$) in Burkina Faso and Debt(current US$) in Guyana?
Your answer should be compact. 1.64e+08. In the year 1983, what is the difference between the Debt(current US$) of Burkina Faso and Debt(current US$) of Maldives?
Your response must be concise. 2.74e+08. In the year 1983, what is the difference between the Debt(current US$) in El Salvador and Debt(current US$) in Guyana?
Your answer should be very brief. 2.36e+08. In the year 1983, what is the difference between the Debt(current US$) in El Salvador and Debt(current US$) in Maldives?
Keep it short and to the point. 3.47e+08. In the year 1983, what is the difference between the Debt(current US$) in Guyana and Debt(current US$) in Maldives?
Your answer should be compact. 1.10e+08. In the year 1984, what is the difference between the Debt(current US$) of Burkina Faso and Debt(current US$) of El Salvador?
Give a very brief answer. -6.44e+07. In the year 1984, what is the difference between the Debt(current US$) of Burkina Faso and Debt(current US$) of Guyana?
Offer a very short reply. 1.71e+08. In the year 1984, what is the difference between the Debt(current US$) of Burkina Faso and Debt(current US$) of Maldives?
Provide a short and direct response. 2.83e+08. In the year 1984, what is the difference between the Debt(current US$) in El Salvador and Debt(current US$) in Guyana?
Offer a very short reply. 2.35e+08. In the year 1984, what is the difference between the Debt(current US$) of El Salvador and Debt(current US$) of Maldives?
Keep it short and to the point. 3.48e+08. In the year 1984, what is the difference between the Debt(current US$) in Guyana and Debt(current US$) in Maldives?
Provide a short and direct response. 1.12e+08. In the year 1985, what is the difference between the Debt(current US$) of Burkina Faso and Debt(current US$) of El Salvador?
Your response must be concise. 2.31e+07. In the year 1985, what is the difference between the Debt(current US$) in Burkina Faso and Debt(current US$) in Guyana?
Provide a short and direct response. 2.28e+08. In the year 1985, what is the difference between the Debt(current US$) of Burkina Faso and Debt(current US$) of Maldives?
Offer a terse response. 3.73e+08. In the year 1985, what is the difference between the Debt(current US$) of El Salvador and Debt(current US$) of Guyana?
Ensure brevity in your answer.  2.04e+08. In the year 1985, what is the difference between the Debt(current US$) of El Salvador and Debt(current US$) of Maldives?
Keep it short and to the point. 3.50e+08. In the year 1985, what is the difference between the Debt(current US$) in Guyana and Debt(current US$) in Maldives?
Make the answer very short. 1.46e+08. In the year 1986, what is the difference between the Debt(current US$) of Burkina Faso and Debt(current US$) of El Salvador?
Keep it short and to the point. 1.15e+08. In the year 1986, what is the difference between the Debt(current US$) in Burkina Faso and Debt(current US$) in Guyana?
Offer a very short reply. 2.49e+08. In the year 1986, what is the difference between the Debt(current US$) in Burkina Faso and Debt(current US$) in Maldives?
Keep it short and to the point. 3.74e+08. In the year 1986, what is the difference between the Debt(current US$) in El Salvador and Debt(current US$) in Guyana?
Offer a very short reply. 1.34e+08. In the year 1986, what is the difference between the Debt(current US$) in El Salvador and Debt(current US$) in Maldives?
Ensure brevity in your answer.  2.59e+08. In the year 1986, what is the difference between the Debt(current US$) of Guyana and Debt(current US$) of Maldives?
Keep it short and to the point. 1.25e+08. In the year 1987, what is the difference between the Debt(current US$) of Burkina Faso and Debt(current US$) of El Salvador?
Your answer should be compact. 4.28e+07. In the year 1987, what is the difference between the Debt(current US$) in Burkina Faso and Debt(current US$) in Guyana?
Your response must be concise. 2.57e+08. In the year 1987, what is the difference between the Debt(current US$) of Burkina Faso and Debt(current US$) of Maldives?
Give a very brief answer. 3.69e+08. In the year 1987, what is the difference between the Debt(current US$) of El Salvador and Debt(current US$) of Guyana?
Provide a short and direct response. 2.15e+08. In the year 1987, what is the difference between the Debt(current US$) in El Salvador and Debt(current US$) in Maldives?
Provide a short and direct response. 3.27e+08. In the year 1987, what is the difference between the Debt(current US$) of Guyana and Debt(current US$) of Maldives?
Offer a terse response. 1.12e+08. What is the ratio of the Debt(current US$) in Burkina Faso in 1980 to that in 1981?
Keep it short and to the point. 1.02. What is the ratio of the Debt(current US$) of El Salvador in 1980 to that in 1981?
Provide a succinct answer. 0.95. What is the ratio of the Debt(current US$) of Guyana in 1980 to that in 1981?
Your answer should be very brief. 0.94. What is the ratio of the Debt(current US$) in Maldives in 1980 to that in 1981?
Give a very brief answer. 0.91. What is the ratio of the Debt(current US$) of Burkina Faso in 1980 to that in 1982?
Offer a terse response. 0.71. What is the ratio of the Debt(current US$) of El Salvador in 1980 to that in 1982?
Provide a short and direct response. 0.79. What is the ratio of the Debt(current US$) of Guyana in 1980 to that in 1982?
Give a very brief answer. 1.21. What is the ratio of the Debt(current US$) of Maldives in 1980 to that in 1982?
Keep it short and to the point. 0.98. What is the ratio of the Debt(current US$) of Burkina Faso in 1980 to that in 1983?
Keep it short and to the point. 0.73. What is the ratio of the Debt(current US$) of El Salvador in 1980 to that in 1983?
Make the answer very short. 1.1. What is the ratio of the Debt(current US$) in Guyana in 1980 to that in 1983?
Make the answer very short. 1.6. What is the ratio of the Debt(current US$) of Maldives in 1980 to that in 1983?
Keep it short and to the point. 0.93. What is the ratio of the Debt(current US$) of Burkina Faso in 1980 to that in 1984?
Provide a succinct answer. 0.7. What is the ratio of the Debt(current US$) of El Salvador in 1980 to that in 1984?
Your answer should be very brief. 1.09. What is the ratio of the Debt(current US$) of Guyana in 1980 to that in 1984?
Your answer should be very brief. 1.54. What is the ratio of the Debt(current US$) in Maldives in 1980 to that in 1984?
Give a very brief answer. 0.81. What is the ratio of the Debt(current US$) in Burkina Faso in 1980 to that in 1985?
Offer a very short reply. 0.55. What is the ratio of the Debt(current US$) of El Salvador in 1980 to that in 1985?
Keep it short and to the point. 1.09. What is the ratio of the Debt(current US$) in Guyana in 1980 to that in 1985?
Ensure brevity in your answer.  1.27. What is the ratio of the Debt(current US$) in Maldives in 1980 to that in 1985?
Provide a succinct answer. 1.03. What is the ratio of the Debt(current US$) of Burkina Faso in 1980 to that in 1986?
Make the answer very short. 0.55. What is the ratio of the Debt(current US$) in El Salvador in 1980 to that in 1986?
Provide a succinct answer. 1.47. What is the ratio of the Debt(current US$) of Guyana in 1980 to that in 1986?
Ensure brevity in your answer.  1.5. What is the ratio of the Debt(current US$) of Maldives in 1980 to that in 1986?
Offer a very short reply. 1.26. What is the ratio of the Debt(current US$) in Burkina Faso in 1980 to that in 1987?
Your answer should be compact. 0.54. What is the ratio of the Debt(current US$) of El Salvador in 1980 to that in 1987?
Give a very brief answer. 1.13. What is the ratio of the Debt(current US$) of Guyana in 1980 to that in 1987?
Provide a succinct answer. 1.48. What is the ratio of the Debt(current US$) in Maldives in 1980 to that in 1987?
Your answer should be very brief. 0.66. What is the ratio of the Debt(current US$) of Burkina Faso in 1981 to that in 1982?
Your answer should be compact. 0.69. What is the ratio of the Debt(current US$) in El Salvador in 1981 to that in 1982?
Provide a short and direct response. 0.83. What is the ratio of the Debt(current US$) in Guyana in 1981 to that in 1982?
Ensure brevity in your answer.  1.28. What is the ratio of the Debt(current US$) of Maldives in 1981 to that in 1982?
Make the answer very short. 1.08. What is the ratio of the Debt(current US$) of Burkina Faso in 1981 to that in 1983?
Your answer should be compact. 0.71. What is the ratio of the Debt(current US$) in El Salvador in 1981 to that in 1983?
Your response must be concise. 1.16. What is the ratio of the Debt(current US$) in Guyana in 1981 to that in 1983?
Offer a terse response. 1.7. What is the ratio of the Debt(current US$) in Maldives in 1981 to that in 1983?
Provide a short and direct response. 1.03. What is the ratio of the Debt(current US$) in Burkina Faso in 1981 to that in 1984?
Your answer should be compact. 0.68. What is the ratio of the Debt(current US$) in El Salvador in 1981 to that in 1984?
Keep it short and to the point. 1.15. What is the ratio of the Debt(current US$) of Guyana in 1981 to that in 1984?
Give a very brief answer. 1.63. What is the ratio of the Debt(current US$) of Maldives in 1981 to that in 1984?
Your answer should be very brief. 0.89. What is the ratio of the Debt(current US$) of Burkina Faso in 1981 to that in 1985?
Your answer should be very brief. 0.54. What is the ratio of the Debt(current US$) in El Salvador in 1981 to that in 1985?
Provide a succinct answer. 1.15. What is the ratio of the Debt(current US$) in Guyana in 1981 to that in 1985?
Offer a terse response. 1.35. What is the ratio of the Debt(current US$) of Maldives in 1981 to that in 1985?
Offer a terse response. 1.14. What is the ratio of the Debt(current US$) of Burkina Faso in 1981 to that in 1986?
Provide a short and direct response. 0.54. What is the ratio of the Debt(current US$) in El Salvador in 1981 to that in 1986?
Provide a succinct answer. 1.55. What is the ratio of the Debt(current US$) of Guyana in 1981 to that in 1986?
Your answer should be very brief. 1.59. What is the ratio of the Debt(current US$) of Maldives in 1981 to that in 1986?
Your answer should be compact. 1.39. What is the ratio of the Debt(current US$) of Burkina Faso in 1981 to that in 1987?
Your answer should be compact. 0.53. What is the ratio of the Debt(current US$) in El Salvador in 1981 to that in 1987?
Offer a terse response. 1.2. What is the ratio of the Debt(current US$) in Guyana in 1981 to that in 1987?
Provide a short and direct response. 1.57. What is the ratio of the Debt(current US$) of Maldives in 1981 to that in 1987?
Offer a terse response. 0.73. What is the ratio of the Debt(current US$) in Burkina Faso in 1982 to that in 1983?
Make the answer very short. 1.02. What is the ratio of the Debt(current US$) of El Salvador in 1982 to that in 1983?
Provide a succinct answer. 1.39. What is the ratio of the Debt(current US$) of Guyana in 1982 to that in 1983?
Offer a very short reply. 1.32. What is the ratio of the Debt(current US$) in Maldives in 1982 to that in 1983?
Offer a terse response. 0.96. What is the ratio of the Debt(current US$) in Burkina Faso in 1982 to that in 1984?
Your answer should be very brief. 0.98. What is the ratio of the Debt(current US$) of El Salvador in 1982 to that in 1984?
Your response must be concise. 1.37. What is the ratio of the Debt(current US$) of Guyana in 1982 to that in 1984?
Give a very brief answer. 1.27. What is the ratio of the Debt(current US$) in Maldives in 1982 to that in 1984?
Give a very brief answer. 0.83. What is the ratio of the Debt(current US$) of Burkina Faso in 1982 to that in 1985?
Provide a short and direct response. 0.77. What is the ratio of the Debt(current US$) in El Salvador in 1982 to that in 1985?
Offer a very short reply. 1.38. What is the ratio of the Debt(current US$) of Guyana in 1982 to that in 1985?
Your answer should be compact. 1.05. What is the ratio of the Debt(current US$) in Maldives in 1982 to that in 1985?
Keep it short and to the point. 1.06. What is the ratio of the Debt(current US$) in Burkina Faso in 1982 to that in 1986?
Provide a succinct answer. 0.78. What is the ratio of the Debt(current US$) in El Salvador in 1982 to that in 1986?
Your response must be concise. 1.86. What is the ratio of the Debt(current US$) in Guyana in 1982 to that in 1986?
Make the answer very short. 1.24. What is the ratio of the Debt(current US$) of Maldives in 1982 to that in 1986?
Offer a terse response. 1.29. What is the ratio of the Debt(current US$) of Burkina Faso in 1982 to that in 1987?
Give a very brief answer. 0.76. What is the ratio of the Debt(current US$) in El Salvador in 1982 to that in 1987?
Offer a terse response. 1.43. What is the ratio of the Debt(current US$) of Guyana in 1982 to that in 1987?
Ensure brevity in your answer.  1.23. What is the ratio of the Debt(current US$) of Maldives in 1982 to that in 1987?
Ensure brevity in your answer.  0.68. What is the ratio of the Debt(current US$) of Burkina Faso in 1983 to that in 1984?
Make the answer very short. 0.96. What is the ratio of the Debt(current US$) of El Salvador in 1983 to that in 1984?
Give a very brief answer. 0.99. What is the ratio of the Debt(current US$) of Guyana in 1983 to that in 1984?
Your answer should be compact. 0.96. What is the ratio of the Debt(current US$) of Maldives in 1983 to that in 1984?
Ensure brevity in your answer.  0.86. What is the ratio of the Debt(current US$) in Burkina Faso in 1983 to that in 1985?
Provide a succinct answer. 0.75. What is the ratio of the Debt(current US$) in El Salvador in 1983 to that in 1985?
Make the answer very short. 1. What is the ratio of the Debt(current US$) in Guyana in 1983 to that in 1985?
Offer a very short reply. 0.8. What is the ratio of the Debt(current US$) of Maldives in 1983 to that in 1985?
Make the answer very short. 1.11. What is the ratio of the Debt(current US$) in Burkina Faso in 1983 to that in 1986?
Give a very brief answer. 0.76. What is the ratio of the Debt(current US$) in El Salvador in 1983 to that in 1986?
Offer a terse response. 1.34. What is the ratio of the Debt(current US$) in Guyana in 1983 to that in 1986?
Ensure brevity in your answer.  0.93. What is the ratio of the Debt(current US$) in Maldives in 1983 to that in 1986?
Your answer should be compact. 1.34. What is the ratio of the Debt(current US$) in Burkina Faso in 1983 to that in 1987?
Offer a very short reply. 0.74. What is the ratio of the Debt(current US$) in El Salvador in 1983 to that in 1987?
Offer a very short reply. 1.03. What is the ratio of the Debt(current US$) of Guyana in 1983 to that in 1987?
Offer a very short reply. 0.93. What is the ratio of the Debt(current US$) of Maldives in 1983 to that in 1987?
Ensure brevity in your answer.  0.71. What is the ratio of the Debt(current US$) of Burkina Faso in 1984 to that in 1985?
Your answer should be compact. 0.78. What is the ratio of the Debt(current US$) of El Salvador in 1984 to that in 1985?
Keep it short and to the point. 1.01. What is the ratio of the Debt(current US$) in Guyana in 1984 to that in 1985?
Your answer should be compact. 0.83. What is the ratio of the Debt(current US$) of Maldives in 1984 to that in 1985?
Offer a very short reply. 1.28. What is the ratio of the Debt(current US$) of Burkina Faso in 1984 to that in 1986?
Give a very brief answer. 0.79. What is the ratio of the Debt(current US$) in El Salvador in 1984 to that in 1986?
Provide a succinct answer. 1.36. What is the ratio of the Debt(current US$) of Guyana in 1984 to that in 1986?
Make the answer very short. 0.97. What is the ratio of the Debt(current US$) of Maldives in 1984 to that in 1986?
Provide a short and direct response. 1.56. What is the ratio of the Debt(current US$) of Burkina Faso in 1984 to that in 1987?
Make the answer very short. 0.77. What is the ratio of the Debt(current US$) in El Salvador in 1984 to that in 1987?
Provide a succinct answer. 1.04. What is the ratio of the Debt(current US$) of Guyana in 1984 to that in 1987?
Offer a terse response. 0.96. What is the ratio of the Debt(current US$) in Maldives in 1984 to that in 1987?
Provide a succinct answer. 0.82. What is the ratio of the Debt(current US$) of Burkina Faso in 1985 to that in 1986?
Your answer should be compact. 1.01. What is the ratio of the Debt(current US$) in El Salvador in 1985 to that in 1986?
Ensure brevity in your answer.  1.35. What is the ratio of the Debt(current US$) of Guyana in 1985 to that in 1986?
Your answer should be compact. 1.17. What is the ratio of the Debt(current US$) of Maldives in 1985 to that in 1986?
Make the answer very short. 1.21. What is the ratio of the Debt(current US$) of El Salvador in 1985 to that in 1987?
Your answer should be very brief. 1.04. What is the ratio of the Debt(current US$) in Guyana in 1985 to that in 1987?
Your answer should be very brief. 1.16. What is the ratio of the Debt(current US$) of Maldives in 1985 to that in 1987?
Give a very brief answer. 0.64. What is the ratio of the Debt(current US$) in Burkina Faso in 1986 to that in 1987?
Give a very brief answer. 0.98. What is the ratio of the Debt(current US$) of El Salvador in 1986 to that in 1987?
Your answer should be compact. 0.77. What is the ratio of the Debt(current US$) in Maldives in 1986 to that in 1987?
Keep it short and to the point. 0.52. What is the difference between the highest and the second highest Debt(current US$) of Burkina Faso?
Provide a short and direct response. 6.79e+06. What is the difference between the highest and the second highest Debt(current US$) in El Salvador?
Make the answer very short. 8.48e+07. What is the difference between the highest and the second highest Debt(current US$) of Guyana?
Ensure brevity in your answer.  1.29e+07. What is the difference between the highest and the second highest Debt(current US$) in Maldives?
Make the answer very short. 5.31e+06. What is the difference between the highest and the lowest Debt(current US$) in Burkina Faso?
Your answer should be very brief. 1.89e+08. What is the difference between the highest and the lowest Debt(current US$) in El Salvador?
Ensure brevity in your answer.  2.37e+08. What is the difference between the highest and the lowest Debt(current US$) of Guyana?
Ensure brevity in your answer.  9.15e+07. What is the difference between the highest and the lowest Debt(current US$) in Maldives?
Keep it short and to the point. 1.38e+07. 